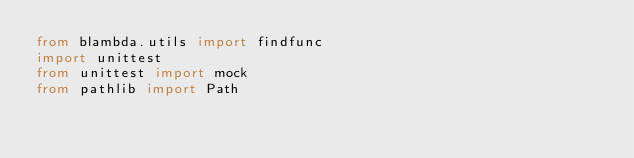<code> <loc_0><loc_0><loc_500><loc_500><_Python_>from blambda.utils import findfunc
import unittest
from unittest import mock
from pathlib import Path
</code> 